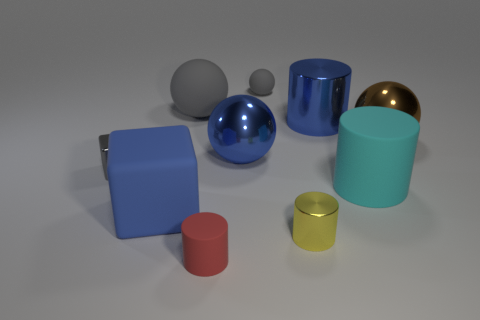Do the rubber cube and the large metallic cylinder have the same color?
Offer a terse response. Yes. What shape is the cyan matte object that is the same size as the brown metal sphere?
Provide a short and direct response. Cylinder. What size is the cyan matte object?
Offer a terse response. Large. There is a yellow cylinder that is in front of the big rubber cube; does it have the same size as the gray thing in front of the big brown thing?
Provide a short and direct response. Yes. There is a small rubber thing behind the small gray object that is in front of the big blue sphere; what is its color?
Provide a short and direct response. Gray. What material is the block that is the same size as the yellow object?
Keep it short and to the point. Metal. How many metallic things are either tiny yellow cylinders or green balls?
Offer a very short reply. 1. What color is the large object that is both to the right of the blue shiny cylinder and in front of the brown metallic object?
Your answer should be compact. Cyan. What number of red matte cylinders are behind the tiny gray sphere?
Your answer should be compact. 0. What material is the yellow cylinder?
Give a very brief answer. Metal. 